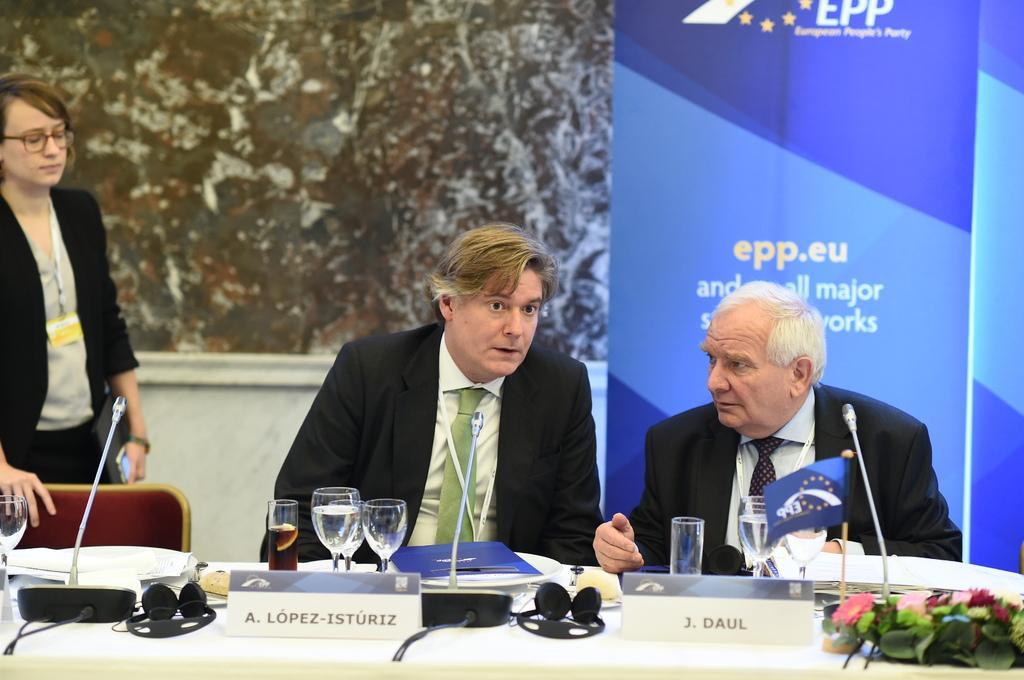Describe this image in one or two sentences. On the left side, there is a woman in black color jacket placing a hand on a chair and standing. There are two persons in black color suits, sitting in front of a table on which, there are glasses, mics arranged, name boards arranged and other objects. In the background, there is a blue color hoarding and there is white wall. 